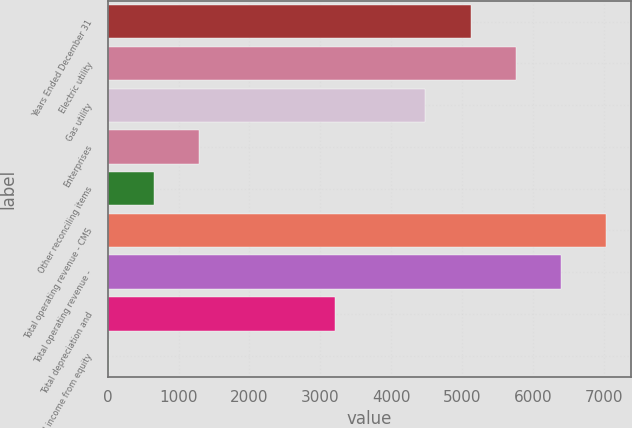Convert chart. <chart><loc_0><loc_0><loc_500><loc_500><bar_chart><fcel>Years Ended December 31<fcel>Electric utility<fcel>Gas utility<fcel>Enterprises<fcel>Other reconciling items<fcel>Total operating revenue - CMS<fcel>Total operating revenue -<fcel>Total depreciation and<fcel>Total income from equity<nl><fcel>5121.8<fcel>5760.4<fcel>4483.2<fcel>1290.2<fcel>651.6<fcel>7037.6<fcel>6399<fcel>3206<fcel>13<nl></chart> 